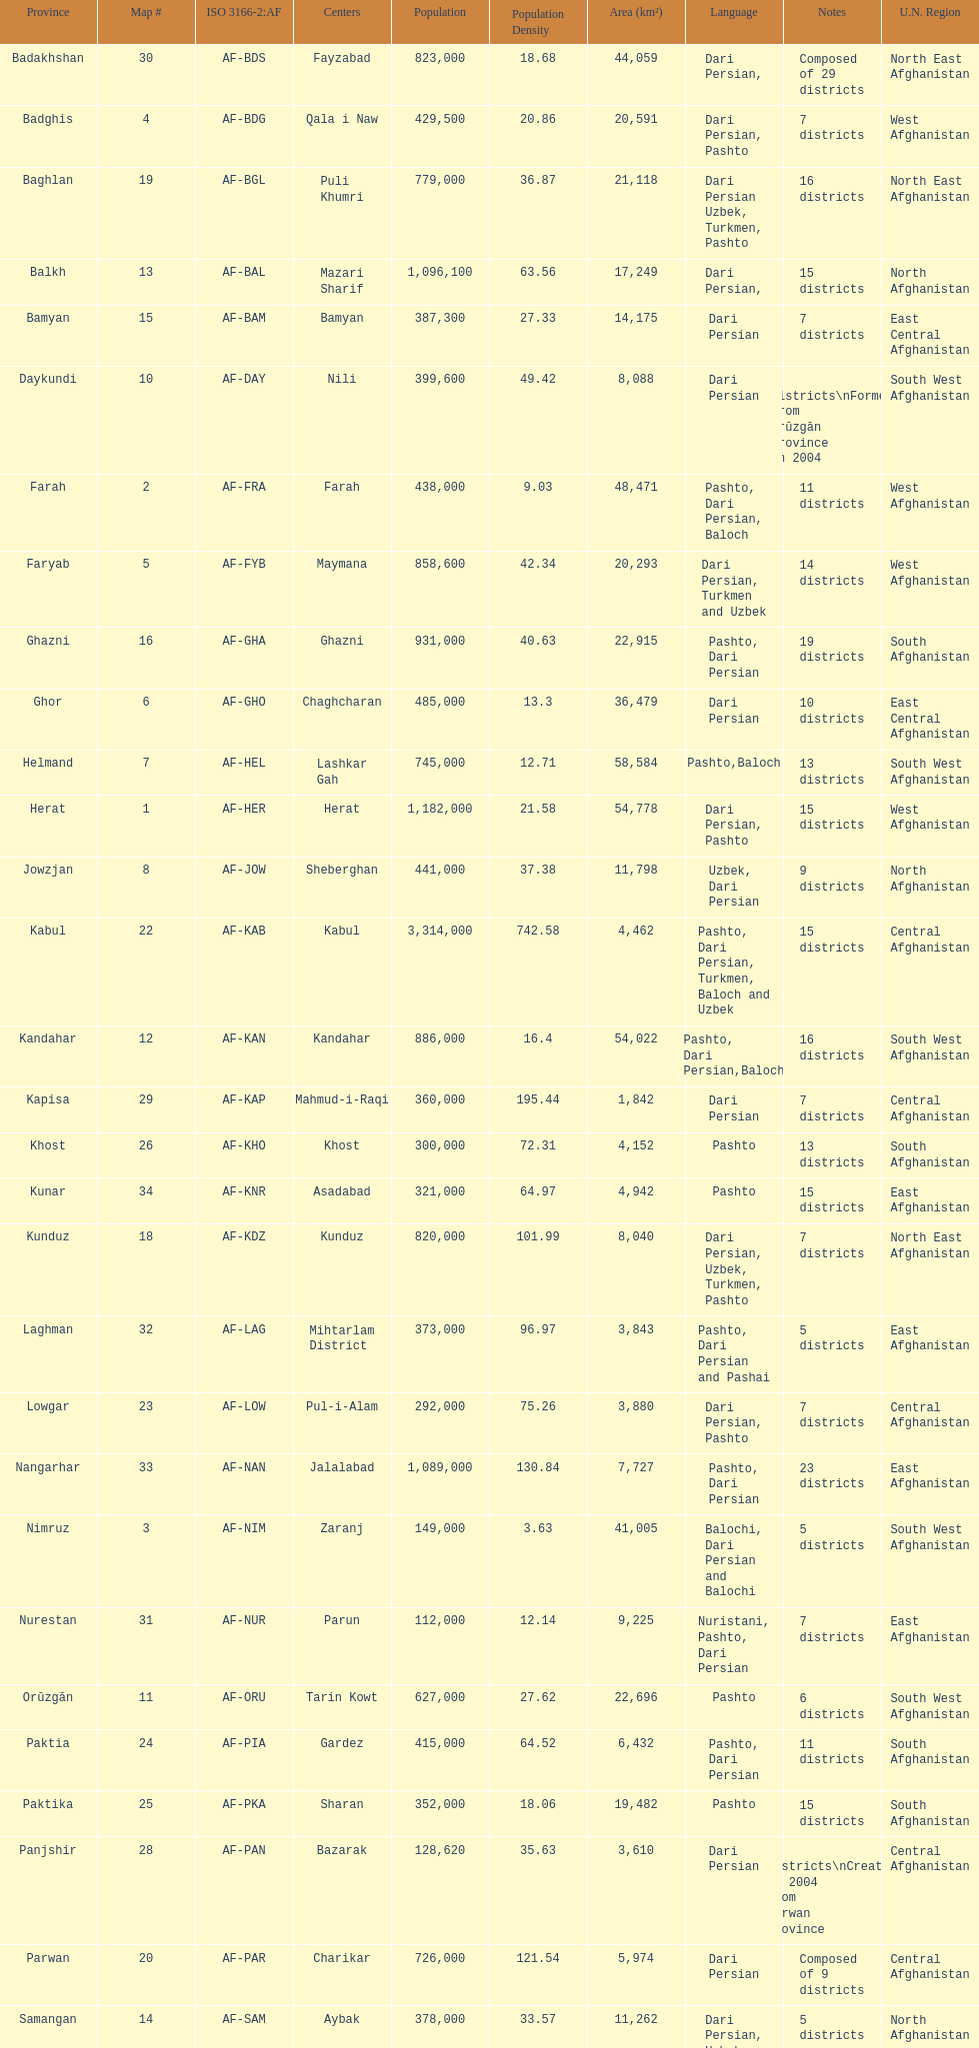In how many regions in afghanistan do they speak dari persian? 28. 